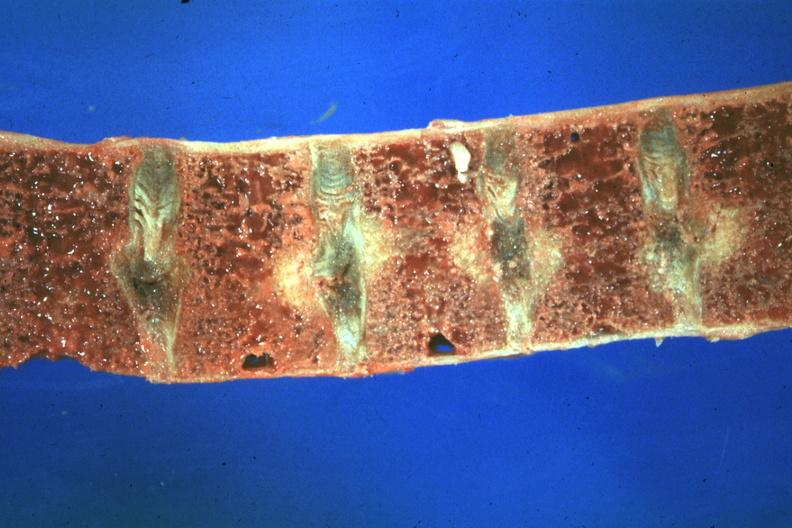what does this image show?
Answer the question using a single word or phrase. Close-up view very good case of 48yowm with hypertension renal failure and secondary parathyroid hyperplasia 